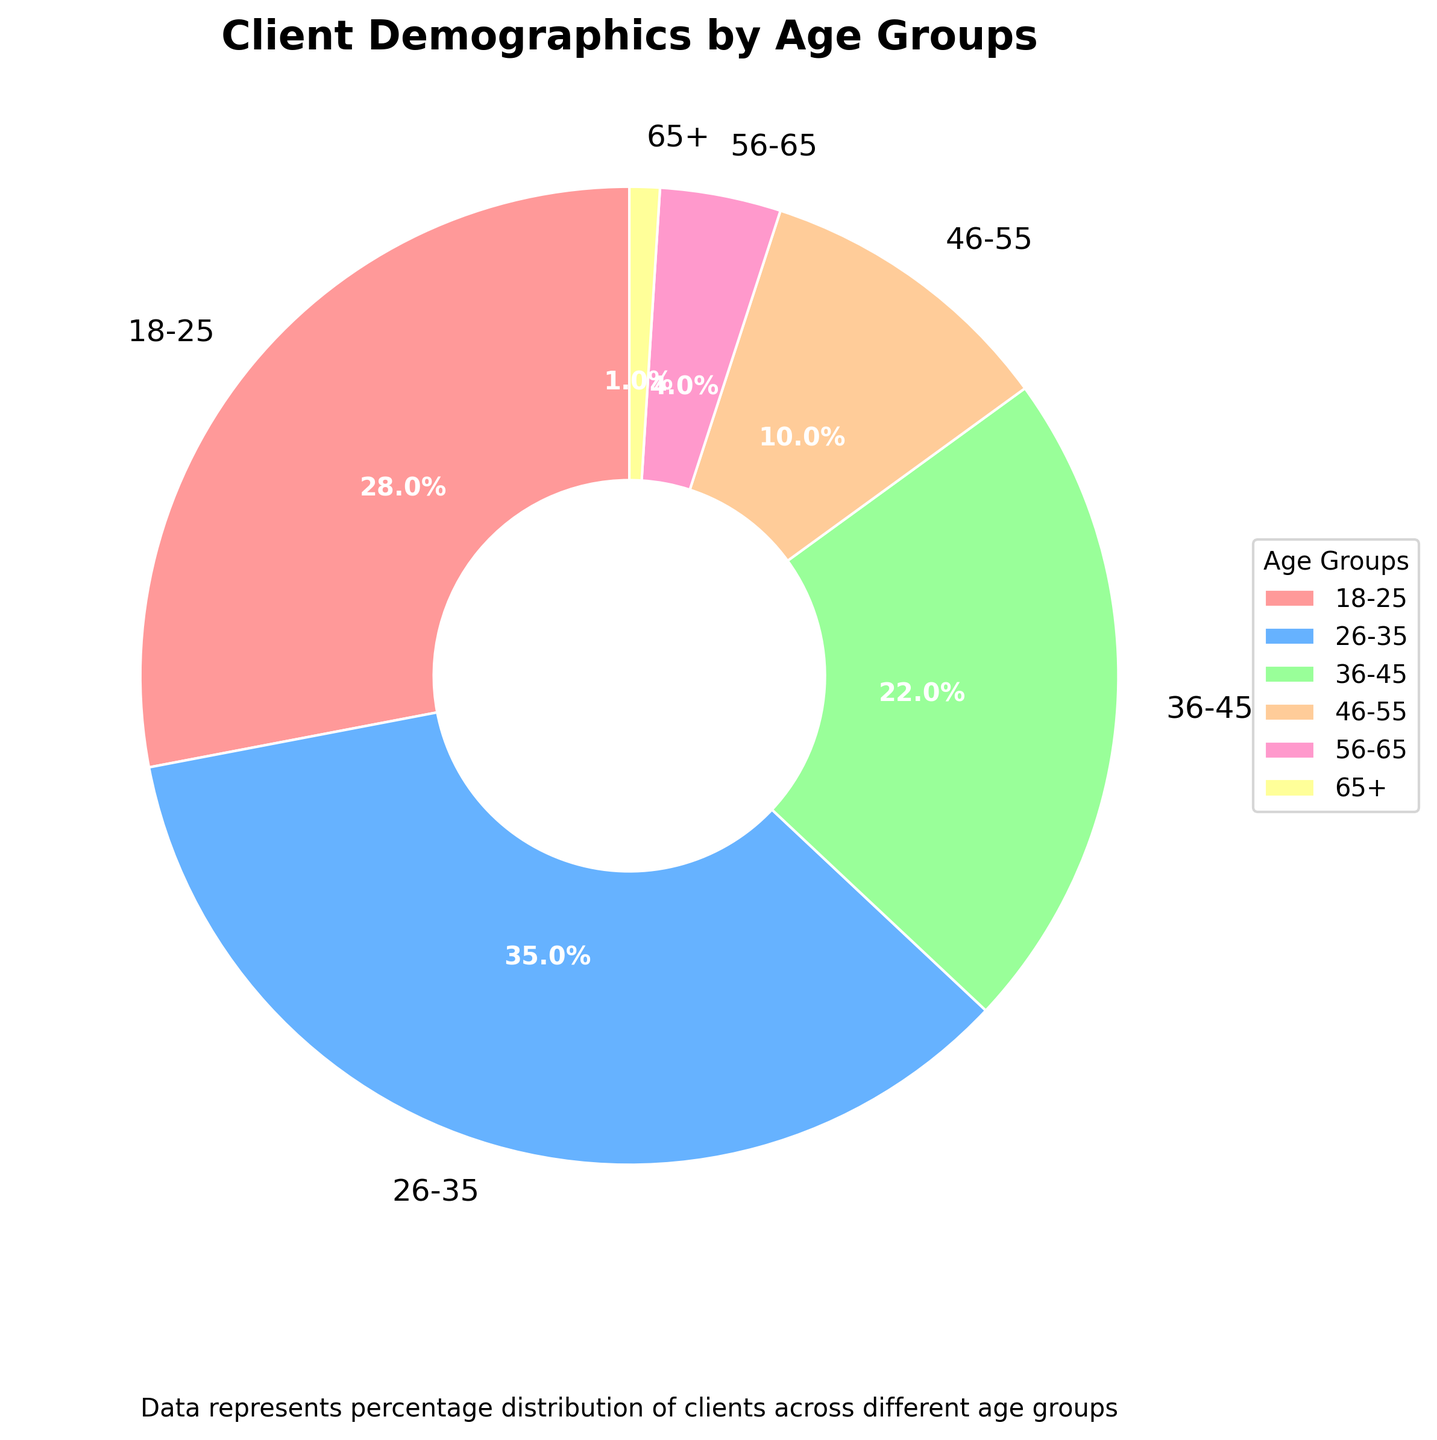What is the percentage of clients aged 26-35? The pie chart shows the breakdown of percentages for each age group. By directly looking at the chart or the legend, the percentage for the age group 26-35 is given.
Answer: 35% Which age group has the smallest percentage of clients? To find the smallest percentage, we compare the values of all age groups. From the pie chart, the age group 65+ has the smallest portion.
Answer: 65+ How much larger is the percentage of clients aged 18-25 compared to those aged 46-55? First, find the percentages for both age groups. The percentage for 18-25 is 28%, and for 46-55 it is 10%. Subtract the smaller percentage from the larger one: 28% - 10% = 18%.
Answer: 18% What is the combined percentage of clients aged 36-45 and 46-55? Sum the percentages of the two age groups. The chart shows that 36-45 is 22% and 46-55 is 10%. Add them together: 22% + 10% = 32%.
Answer: 32% Which age group has the highest percentage of clients? By comparing all the age groups, the chart indicates that the age group 26-35 has the highest percentage.
Answer: 26-35 How much more in percentage is the 26-35 age group compared to the 56-65 age group? Find the difference between the percentages of the two age groups: 26-35 is 35%, and 56-65 is 4%. Subtract the smaller percentage from the larger one: 35% - 4% = 31%.
Answer: 31% If you combine the percentages of clients aged 18-25, 36-45, and 46-55, what total percentage do you get? Sum the percentages of the three age groups: 18-25 is 28%, 36-45 is 22%, and 46-55 is 10%. Adding them together: 28% + 22% + 10% = 60%.
Answer: 60% Which color represents the age group with the lowest percentage? By identifying the colors linked to each age group, it shows the 65+ age group has the lowest percentage. The color associated with this group is examined on the pie chart.
Answer: Yellow (assuming yellow based on commonly used color codes for age groups) What is the difference in combined percentages between age groups 18-25 and 36-45 compared to age groups 46-55 and 65+? First, calculate the combined percentage for 18-25 and 36-45: 28% + 22% = 50%. Then, calculate the combined percentage for 46-55 and 65+: 10% + 1% = 11%. Finally, find the difference: 50% - 11% = 39%.
Answer: 39% What is the total percentage of clients older than 45 years? Add the percentages for all age groups above 45 years: 46-55 (10%), 56-65 (4%), and 65+ (1%). The total is: 10% + 4% + 1% = 15%.
Answer: 15% 